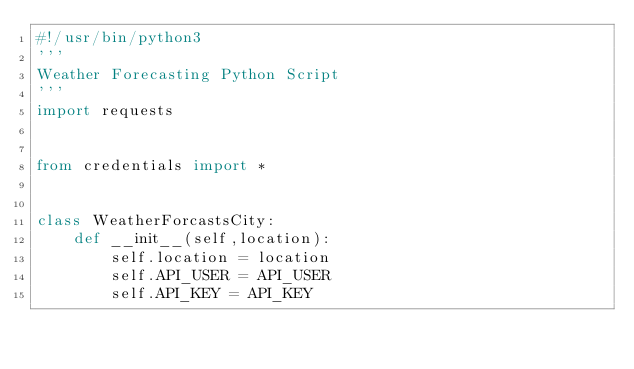Convert code to text. <code><loc_0><loc_0><loc_500><loc_500><_Python_>#!/usr/bin/python3
'''
Weather Forecasting Python Script
'''
import requests


from credentials import *


class WeatherForcastsCity:
    def __init__(self,location):
        self.location = location
        self.API_USER = API_USER
        self.API_KEY = API_KEY</code> 